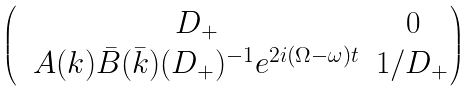Convert formula to latex. <formula><loc_0><loc_0><loc_500><loc_500>\begin{pmatrix} & D _ { + } & 0 \\ & A ( k ) \bar { B } ( \bar { k } ) ( D _ { + } ) ^ { - 1 } e ^ { 2 i ( \Omega - \omega ) t } & 1 / D _ { + } \end{pmatrix}</formula> 